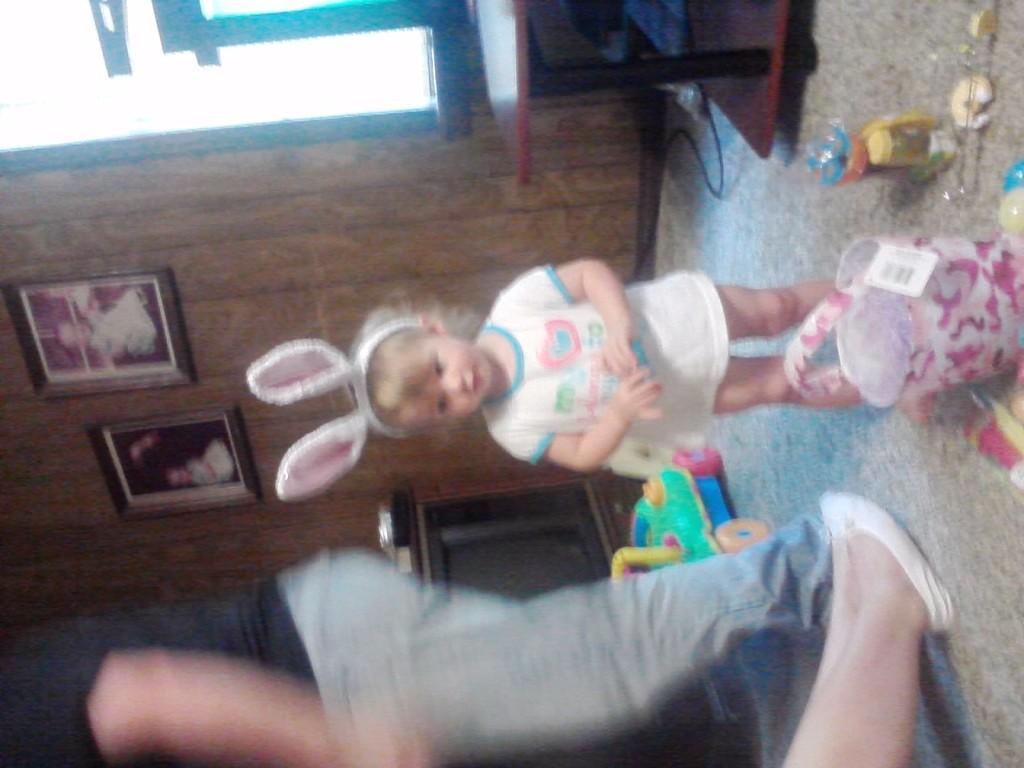Please provide a concise description of this image. In this picture we can see the floor, on this floor we can see a child, person, person's legs, bucket and few objects and in the background we can see a television, table, photo frames and the wall. 